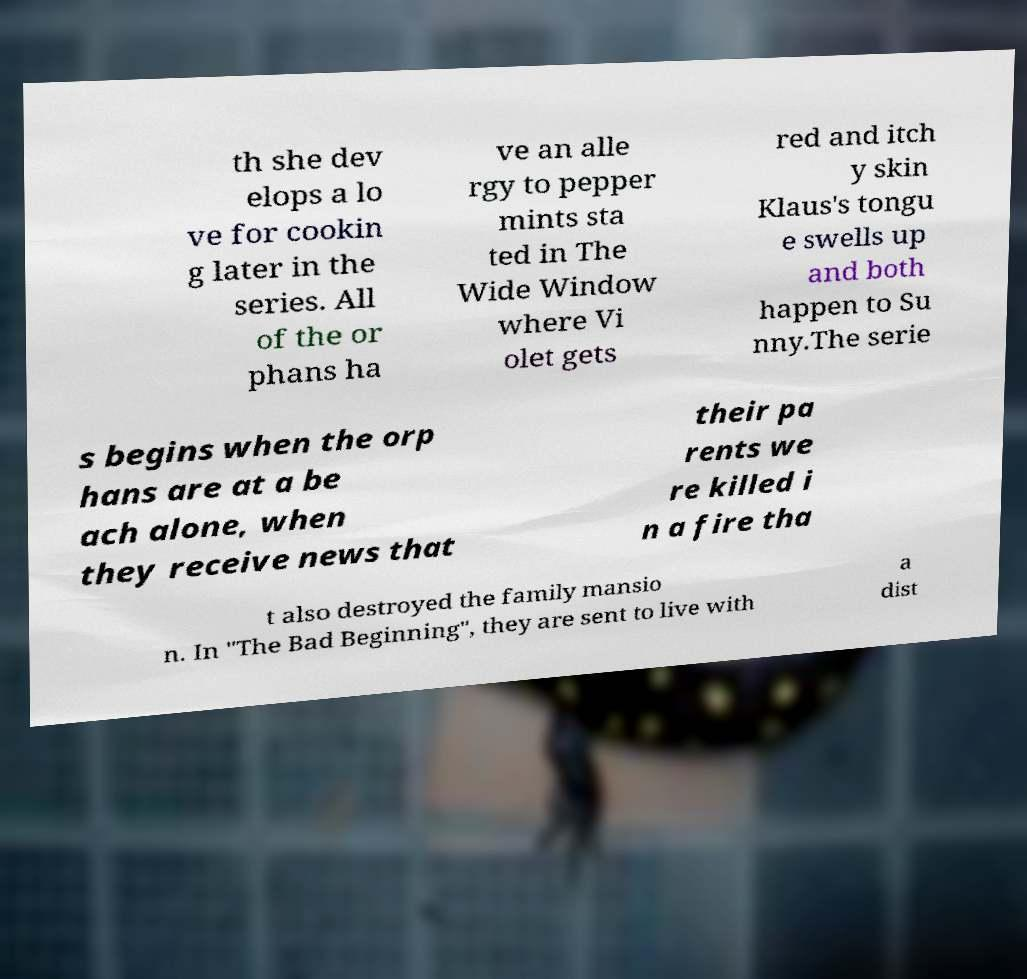Could you assist in decoding the text presented in this image and type it out clearly? th she dev elops a lo ve for cookin g later in the series. All of the or phans ha ve an alle rgy to pepper mints sta ted in The Wide Window where Vi olet gets red and itch y skin Klaus's tongu e swells up and both happen to Su nny.The serie s begins when the orp hans are at a be ach alone, when they receive news that their pa rents we re killed i n a fire tha t also destroyed the family mansio n. In "The Bad Beginning", they are sent to live with a dist 